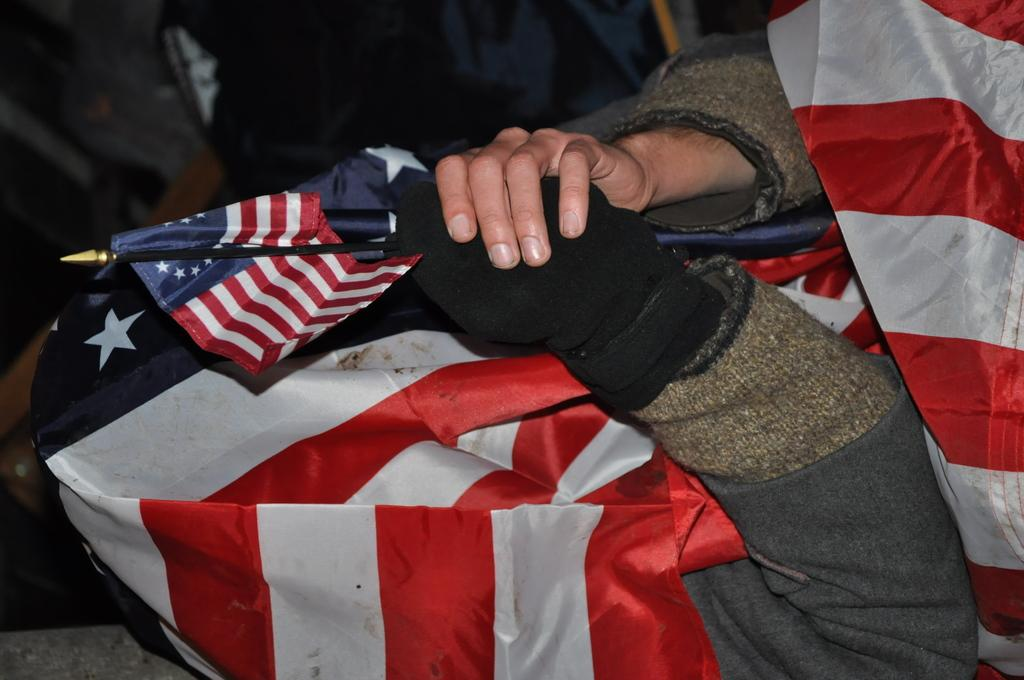What is the person holding in the image? The person's hands are holding a flag in the image. What else can be seen in the image besides the person's hands and the flag? There is a cloth visible in the image. What type of pet can be seen playing with a stamp in the image? There is no pet or stamp present in the image. 